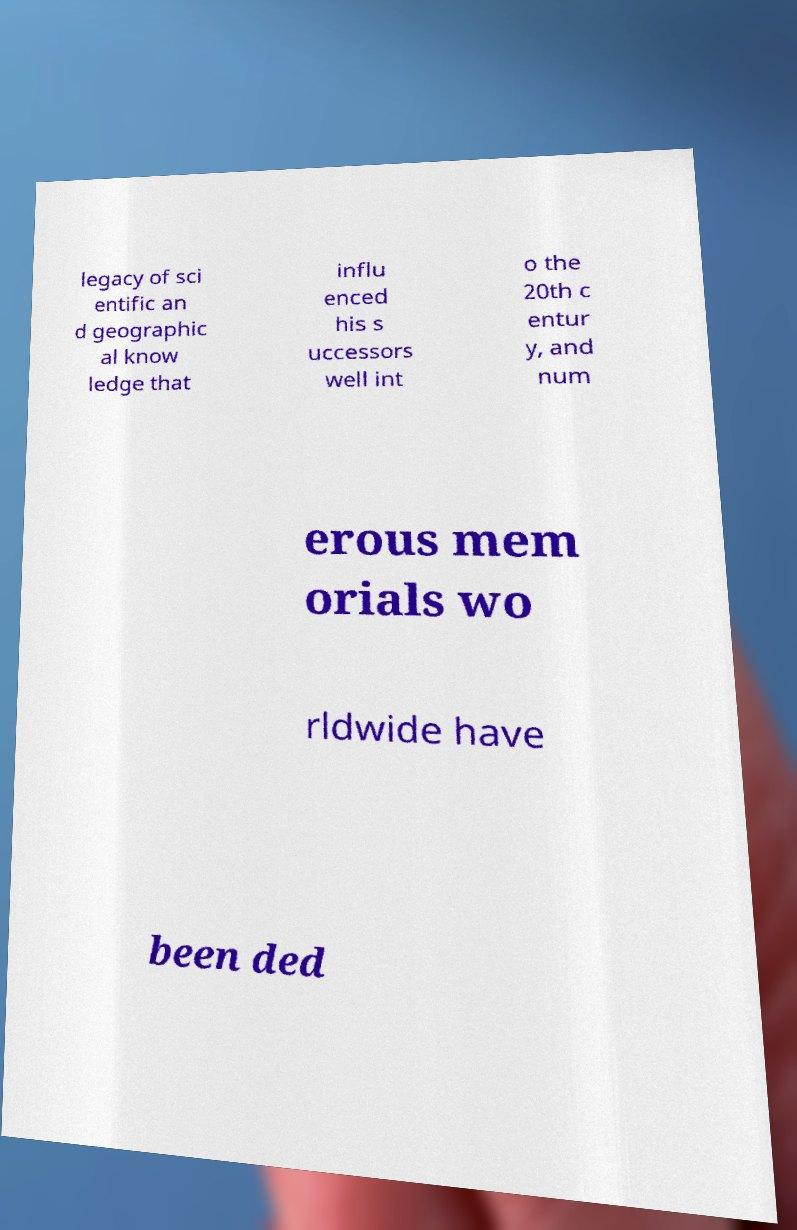For documentation purposes, I need the text within this image transcribed. Could you provide that? legacy of sci entific an d geographic al know ledge that influ enced his s uccessors well int o the 20th c entur y, and num erous mem orials wo rldwide have been ded 